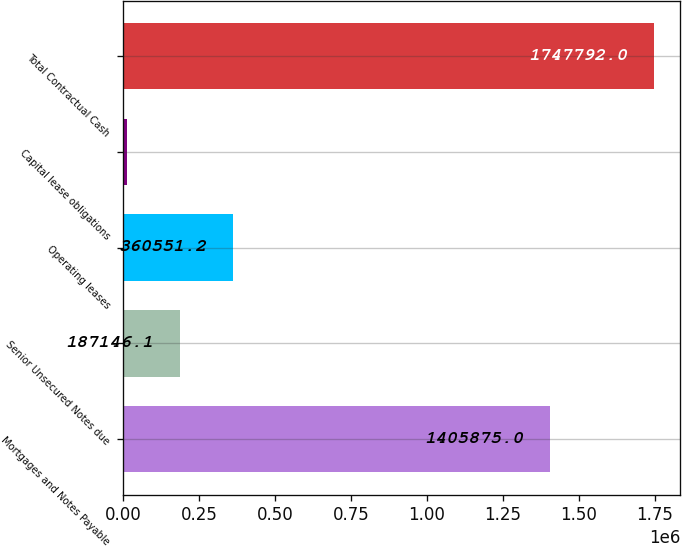<chart> <loc_0><loc_0><loc_500><loc_500><bar_chart><fcel>Mortgages and Notes Payable<fcel>Senior Unsecured Notes due<fcel>Operating leases<fcel>Capital lease obligations<fcel>Total Contractual Cash<nl><fcel>1.40588e+06<fcel>187146<fcel>360551<fcel>13741<fcel>1.74779e+06<nl></chart> 